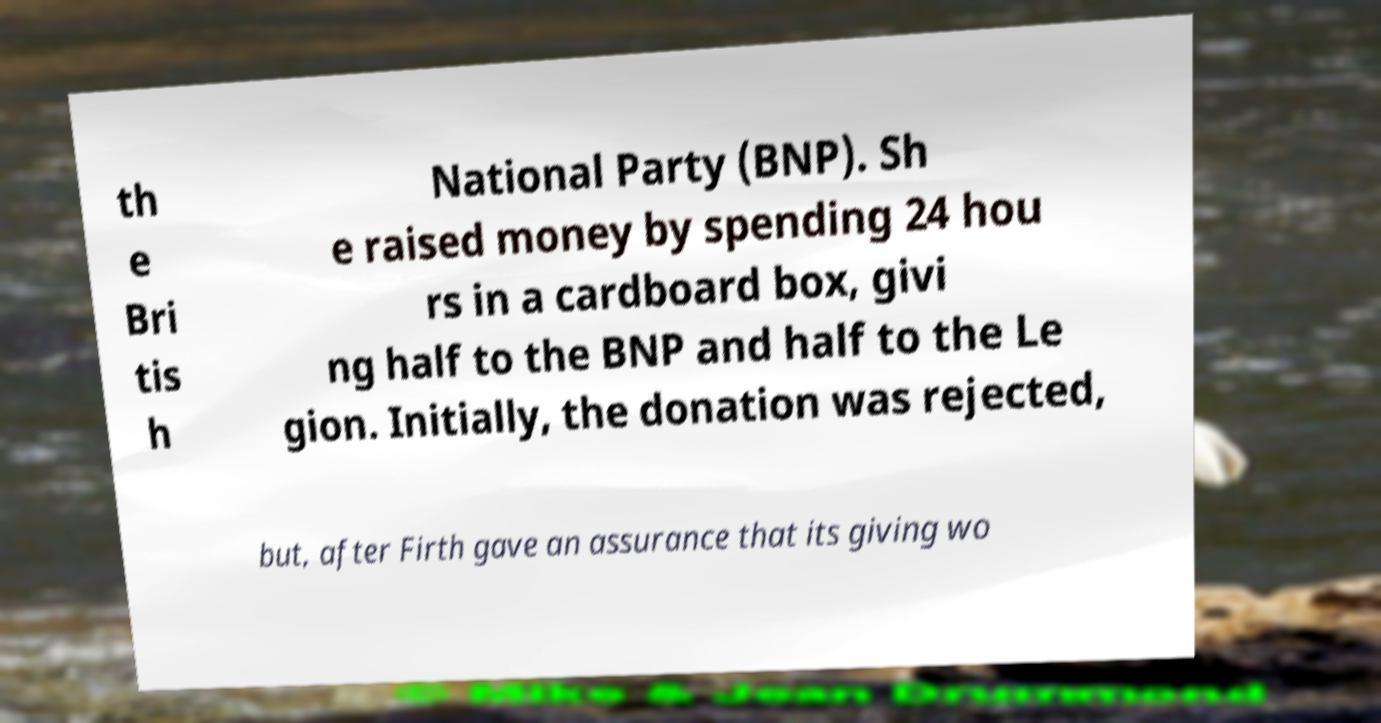Can you read and provide the text displayed in the image?This photo seems to have some interesting text. Can you extract and type it out for me? th e Bri tis h National Party (BNP). Sh e raised money by spending 24 hou rs in a cardboard box, givi ng half to the BNP and half to the Le gion. Initially, the donation was rejected, but, after Firth gave an assurance that its giving wo 